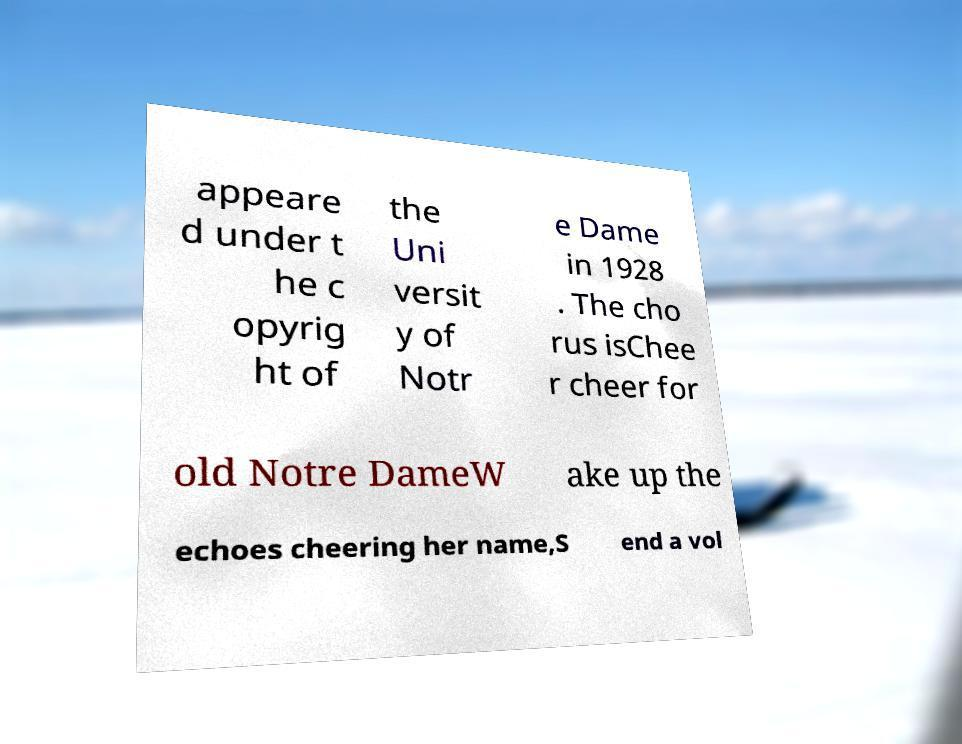What messages or text are displayed in this image? I need them in a readable, typed format. appeare d under t he c opyrig ht of the Uni versit y of Notr e Dame in 1928 . The cho rus isChee r cheer for old Notre DameW ake up the echoes cheering her name,S end a vol 